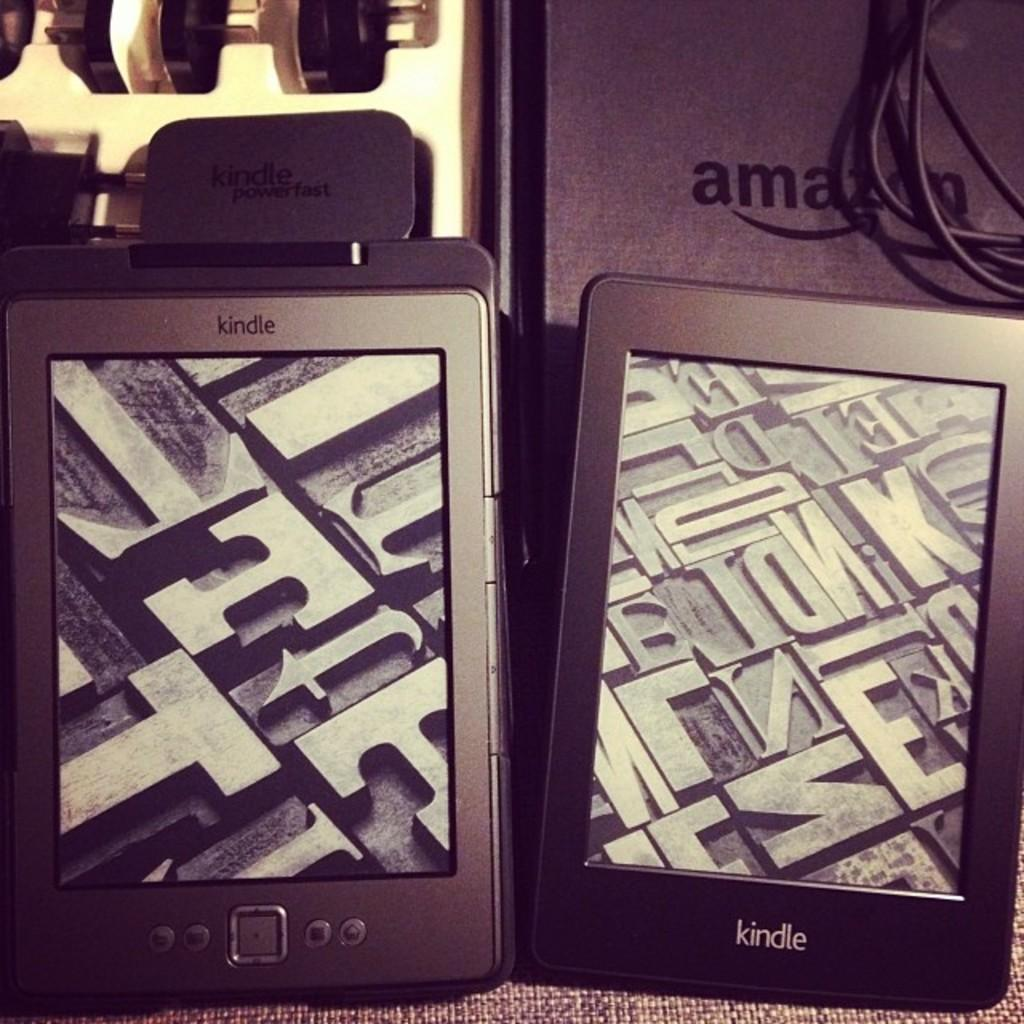Provide a one-sentence caption for the provided image. Two Kindle pads from Amazon side by side on mat. 